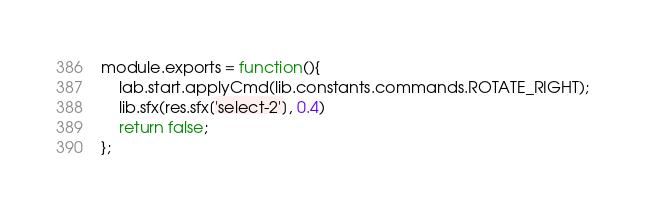<code> <loc_0><loc_0><loc_500><loc_500><_JavaScript_>module.exports = function(){
    lab.start.applyCmd(lib.constants.commands.ROTATE_RIGHT);
    lib.sfx(res.sfx['select-2'], 0.4)
    return false;
};
</code> 